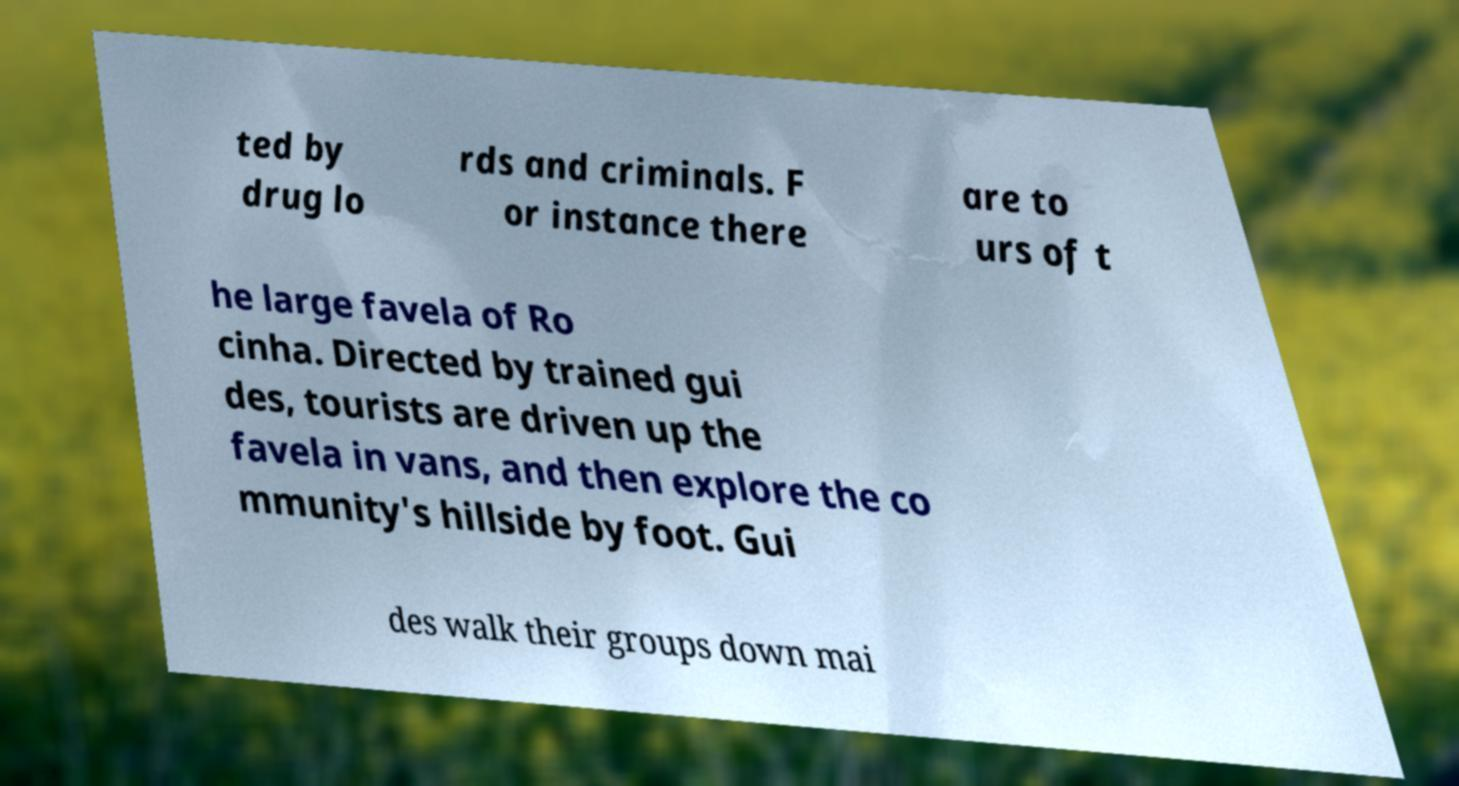There's text embedded in this image that I need extracted. Can you transcribe it verbatim? ted by drug lo rds and criminals. F or instance there are to urs of t he large favela of Ro cinha. Directed by trained gui des, tourists are driven up the favela in vans, and then explore the co mmunity's hillside by foot. Gui des walk their groups down mai 